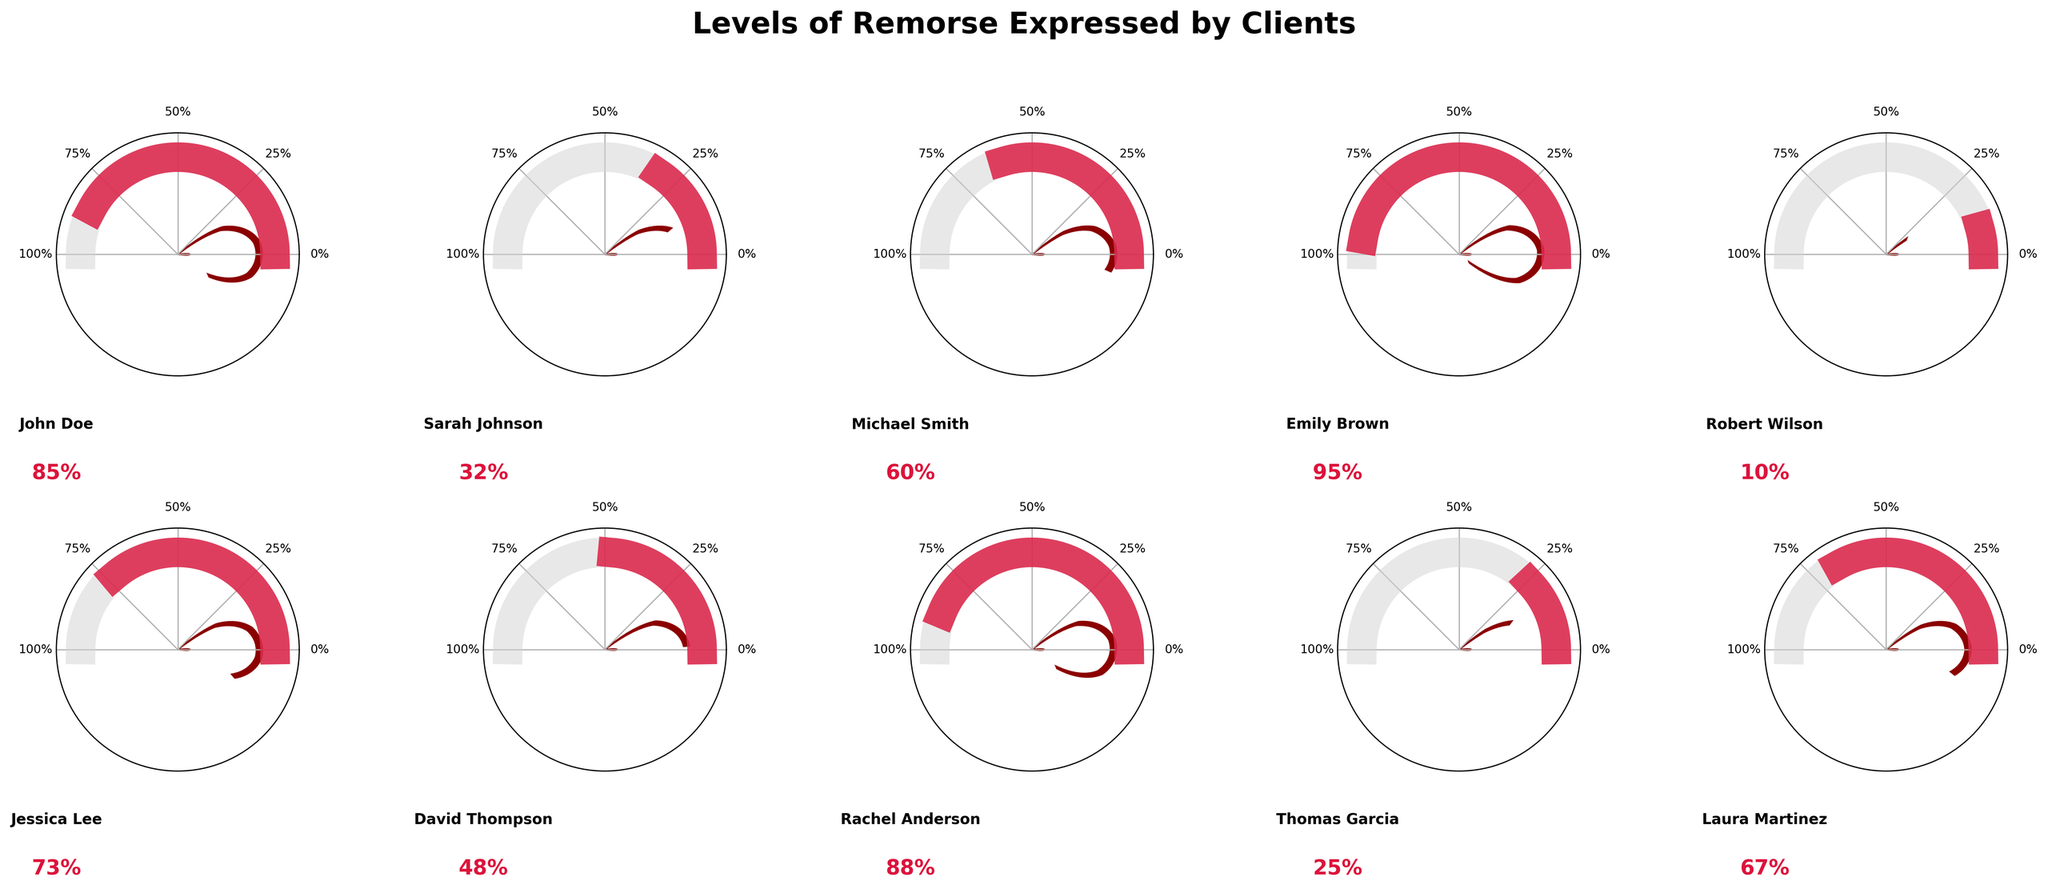What is the title of the figure? The title is displayed at the top of the figure. It is written in bold and large font.
Answer: Levels of Remorse Expressed by Clients Which client shows the highest level of remorse? Look for the client with the gauge closest to 100%.
Answer: Emily Brown Which client expresses the least remorse? Identify the client whose gauge is closest to 0%.
Answer: Robert Wilson How many clients have expressed remorse greater than 50%? Count the number of clients with gauges that exceed the 50% mark.
Answer: 6 What is the average level of remorse across all clients? Add up all the percentages and divide by the number of clients. (85 + 32 + 60 + 95 + 10 + 73 + 48 + 88 + 25 + 67) / 10 = 58.3%
Answer: 58.3% Compare the level of remorse between Rachel Anderson and David Thompson. Who feels more remorse? Compare the percentage values next to "Rachel Anderson" and "David Thompson".
Answer: Rachel Anderson How does Jessica Lee's level of remorse compare to Thomas Garcia's? Compare the percentage values next to "Jessica Lee" and "Thomas Garcia".
Answer: Jessica Lee expresses more remorse Which clients have a remorse level between 30% and 60%? Identify clients with gauges showing percentages between 30% and 60%.
Answer: Sarah Johnson, Michael Smith, David Thompson Is there a client with exactly 60% remorse? Check if any client's gauge shows exactly 60%.
Answer: Yes, Michael Smith What is the difference in remorse levels between John Doe and Robert Wilson? Subtract Robert Wilson's remorse percentage from John Doe's. 85 - 10 = 75%
Answer: 75% 